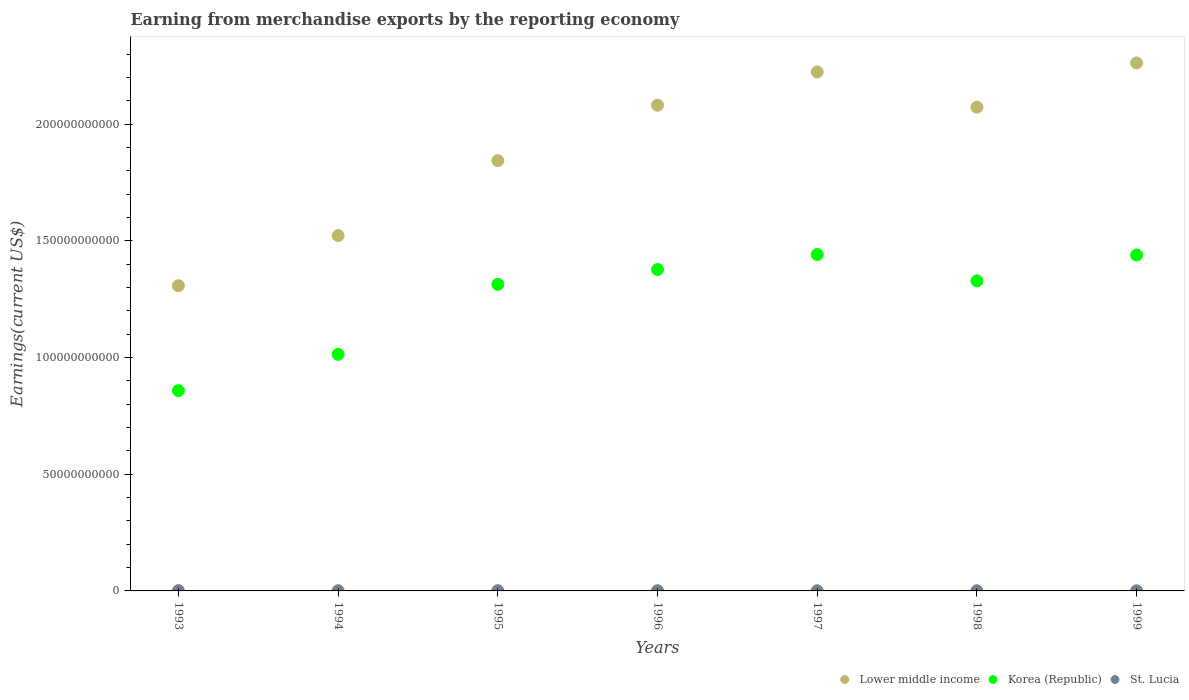How many different coloured dotlines are there?
Give a very brief answer. 3. Is the number of dotlines equal to the number of legend labels?
Offer a terse response. Yes. What is the amount earned from merchandise exports in Lower middle income in 1995?
Make the answer very short. 1.84e+11. Across all years, what is the maximum amount earned from merchandise exports in Lower middle income?
Offer a terse response. 2.26e+11. Across all years, what is the minimum amount earned from merchandise exports in Lower middle income?
Make the answer very short. 1.31e+11. In which year was the amount earned from merchandise exports in Korea (Republic) maximum?
Your response must be concise. 1997. In which year was the amount earned from merchandise exports in Lower middle income minimum?
Your answer should be compact. 1993. What is the total amount earned from merchandise exports in St. Lucia in the graph?
Make the answer very short. 5.82e+08. What is the difference between the amount earned from merchandise exports in Lower middle income in 1994 and that in 1996?
Your answer should be very brief. -5.59e+1. What is the difference between the amount earned from merchandise exports in Korea (Republic) in 1999 and the amount earned from merchandise exports in St. Lucia in 1996?
Offer a very short reply. 1.44e+11. What is the average amount earned from merchandise exports in Korea (Republic) per year?
Offer a very short reply. 1.25e+11. In the year 1996, what is the difference between the amount earned from merchandise exports in Korea (Republic) and amount earned from merchandise exports in St. Lucia?
Provide a short and direct response. 1.38e+11. In how many years, is the amount earned from merchandise exports in St. Lucia greater than 30000000000 US$?
Provide a succinct answer. 0. What is the ratio of the amount earned from merchandise exports in St. Lucia in 1994 to that in 1998?
Provide a succinct answer. 1.52. What is the difference between the highest and the second highest amount earned from merchandise exports in Lower middle income?
Offer a very short reply. 3.85e+09. What is the difference between the highest and the lowest amount earned from merchandise exports in St. Lucia?
Ensure brevity in your answer.  6.40e+07. In how many years, is the amount earned from merchandise exports in St. Lucia greater than the average amount earned from merchandise exports in St. Lucia taken over all years?
Ensure brevity in your answer.  3. Is the sum of the amount earned from merchandise exports in St. Lucia in 1995 and 1996 greater than the maximum amount earned from merchandise exports in Korea (Republic) across all years?
Give a very brief answer. No. Is the amount earned from merchandise exports in Lower middle income strictly less than the amount earned from merchandise exports in Korea (Republic) over the years?
Make the answer very short. No. How many dotlines are there?
Offer a very short reply. 3. How many years are there in the graph?
Ensure brevity in your answer.  7. What is the difference between two consecutive major ticks on the Y-axis?
Your answer should be very brief. 5.00e+1. Are the values on the major ticks of Y-axis written in scientific E-notation?
Your answer should be compact. No. Does the graph contain grids?
Provide a short and direct response. No. How many legend labels are there?
Keep it short and to the point. 3. How are the legend labels stacked?
Your answer should be very brief. Horizontal. What is the title of the graph?
Your answer should be compact. Earning from merchandise exports by the reporting economy. What is the label or title of the X-axis?
Your response must be concise. Years. What is the label or title of the Y-axis?
Keep it short and to the point. Earnings(current US$). What is the Earnings(current US$) in Lower middle income in 1993?
Offer a very short reply. 1.31e+11. What is the Earnings(current US$) of Korea (Republic) in 1993?
Your response must be concise. 8.58e+1. What is the Earnings(current US$) in St. Lucia in 1993?
Provide a succinct answer. 1.20e+08. What is the Earnings(current US$) in Lower middle income in 1994?
Give a very brief answer. 1.52e+11. What is the Earnings(current US$) of Korea (Republic) in 1994?
Provide a succinct answer. 1.01e+11. What is the Earnings(current US$) in St. Lucia in 1994?
Give a very brief answer. 9.44e+07. What is the Earnings(current US$) in Lower middle income in 1995?
Provide a short and direct response. 1.84e+11. What is the Earnings(current US$) of Korea (Republic) in 1995?
Make the answer very short. 1.31e+11. What is the Earnings(current US$) in St. Lucia in 1995?
Make the answer very short. 1.09e+08. What is the Earnings(current US$) of Lower middle income in 1996?
Keep it short and to the point. 2.08e+11. What is the Earnings(current US$) of Korea (Republic) in 1996?
Give a very brief answer. 1.38e+11. What is the Earnings(current US$) of St. Lucia in 1996?
Your response must be concise. 7.96e+07. What is the Earnings(current US$) of Lower middle income in 1997?
Provide a succinct answer. 2.22e+11. What is the Earnings(current US$) of Korea (Republic) in 1997?
Your answer should be compact. 1.44e+11. What is the Earnings(current US$) in St. Lucia in 1997?
Your answer should be very brief. 6.20e+07. What is the Earnings(current US$) of Lower middle income in 1998?
Your response must be concise. 2.07e+11. What is the Earnings(current US$) of Korea (Republic) in 1998?
Make the answer very short. 1.33e+11. What is the Earnings(current US$) in St. Lucia in 1998?
Give a very brief answer. 6.22e+07. What is the Earnings(current US$) of Lower middle income in 1999?
Offer a very short reply. 2.26e+11. What is the Earnings(current US$) of Korea (Republic) in 1999?
Your answer should be compact. 1.44e+11. What is the Earnings(current US$) in St. Lucia in 1999?
Your answer should be compact. 5.56e+07. Across all years, what is the maximum Earnings(current US$) in Lower middle income?
Keep it short and to the point. 2.26e+11. Across all years, what is the maximum Earnings(current US$) of Korea (Republic)?
Give a very brief answer. 1.44e+11. Across all years, what is the maximum Earnings(current US$) in St. Lucia?
Your answer should be very brief. 1.20e+08. Across all years, what is the minimum Earnings(current US$) in Lower middle income?
Offer a very short reply. 1.31e+11. Across all years, what is the minimum Earnings(current US$) in Korea (Republic)?
Make the answer very short. 8.58e+1. Across all years, what is the minimum Earnings(current US$) of St. Lucia?
Make the answer very short. 5.56e+07. What is the total Earnings(current US$) in Lower middle income in the graph?
Offer a terse response. 1.33e+12. What is the total Earnings(current US$) of Korea (Republic) in the graph?
Keep it short and to the point. 8.77e+11. What is the total Earnings(current US$) in St. Lucia in the graph?
Keep it short and to the point. 5.82e+08. What is the difference between the Earnings(current US$) in Lower middle income in 1993 and that in 1994?
Provide a short and direct response. -2.15e+1. What is the difference between the Earnings(current US$) of Korea (Republic) in 1993 and that in 1994?
Offer a terse response. -1.55e+1. What is the difference between the Earnings(current US$) in St. Lucia in 1993 and that in 1994?
Provide a succinct answer. 2.53e+07. What is the difference between the Earnings(current US$) of Lower middle income in 1993 and that in 1995?
Give a very brief answer. -5.36e+1. What is the difference between the Earnings(current US$) in Korea (Republic) in 1993 and that in 1995?
Keep it short and to the point. -4.55e+1. What is the difference between the Earnings(current US$) in St. Lucia in 1993 and that in 1995?
Your response must be concise. 1.07e+07. What is the difference between the Earnings(current US$) in Lower middle income in 1993 and that in 1996?
Your response must be concise. -7.73e+1. What is the difference between the Earnings(current US$) in Korea (Republic) in 1993 and that in 1996?
Your answer should be compact. -5.19e+1. What is the difference between the Earnings(current US$) of St. Lucia in 1993 and that in 1996?
Keep it short and to the point. 4.01e+07. What is the difference between the Earnings(current US$) in Lower middle income in 1993 and that in 1997?
Ensure brevity in your answer.  -9.16e+1. What is the difference between the Earnings(current US$) in Korea (Republic) in 1993 and that in 1997?
Provide a short and direct response. -5.83e+1. What is the difference between the Earnings(current US$) in St. Lucia in 1993 and that in 1997?
Keep it short and to the point. 5.76e+07. What is the difference between the Earnings(current US$) of Lower middle income in 1993 and that in 1998?
Keep it short and to the point. -7.65e+1. What is the difference between the Earnings(current US$) of Korea (Republic) in 1993 and that in 1998?
Your answer should be compact. -4.70e+1. What is the difference between the Earnings(current US$) of St. Lucia in 1993 and that in 1998?
Provide a succinct answer. 5.75e+07. What is the difference between the Earnings(current US$) in Lower middle income in 1993 and that in 1999?
Your answer should be compact. -9.54e+1. What is the difference between the Earnings(current US$) in Korea (Republic) in 1993 and that in 1999?
Provide a short and direct response. -5.81e+1. What is the difference between the Earnings(current US$) in St. Lucia in 1993 and that in 1999?
Your response must be concise. 6.40e+07. What is the difference between the Earnings(current US$) in Lower middle income in 1994 and that in 1995?
Offer a very short reply. -3.21e+1. What is the difference between the Earnings(current US$) of Korea (Republic) in 1994 and that in 1995?
Give a very brief answer. -3.00e+1. What is the difference between the Earnings(current US$) in St. Lucia in 1994 and that in 1995?
Give a very brief answer. -1.46e+07. What is the difference between the Earnings(current US$) in Lower middle income in 1994 and that in 1996?
Your answer should be very brief. -5.59e+1. What is the difference between the Earnings(current US$) in Korea (Republic) in 1994 and that in 1996?
Offer a terse response. -3.63e+1. What is the difference between the Earnings(current US$) of St. Lucia in 1994 and that in 1996?
Provide a succinct answer. 1.48e+07. What is the difference between the Earnings(current US$) of Lower middle income in 1994 and that in 1997?
Make the answer very short. -7.01e+1. What is the difference between the Earnings(current US$) in Korea (Republic) in 1994 and that in 1997?
Provide a succinct answer. -4.28e+1. What is the difference between the Earnings(current US$) in St. Lucia in 1994 and that in 1997?
Ensure brevity in your answer.  3.23e+07. What is the difference between the Earnings(current US$) in Lower middle income in 1994 and that in 1998?
Your response must be concise. -5.50e+1. What is the difference between the Earnings(current US$) in Korea (Republic) in 1994 and that in 1998?
Keep it short and to the point. -3.15e+1. What is the difference between the Earnings(current US$) in St. Lucia in 1994 and that in 1998?
Your response must be concise. 3.22e+07. What is the difference between the Earnings(current US$) of Lower middle income in 1994 and that in 1999?
Provide a succinct answer. -7.40e+1. What is the difference between the Earnings(current US$) in Korea (Republic) in 1994 and that in 1999?
Make the answer very short. -4.26e+1. What is the difference between the Earnings(current US$) in St. Lucia in 1994 and that in 1999?
Your answer should be compact. 3.87e+07. What is the difference between the Earnings(current US$) of Lower middle income in 1995 and that in 1996?
Provide a short and direct response. -2.38e+1. What is the difference between the Earnings(current US$) of Korea (Republic) in 1995 and that in 1996?
Offer a very short reply. -6.36e+09. What is the difference between the Earnings(current US$) of St. Lucia in 1995 and that in 1996?
Your response must be concise. 2.94e+07. What is the difference between the Earnings(current US$) of Lower middle income in 1995 and that in 1997?
Your response must be concise. -3.80e+1. What is the difference between the Earnings(current US$) of Korea (Republic) in 1995 and that in 1997?
Provide a succinct answer. -1.28e+1. What is the difference between the Earnings(current US$) of St. Lucia in 1995 and that in 1997?
Offer a very short reply. 4.70e+07. What is the difference between the Earnings(current US$) of Lower middle income in 1995 and that in 1998?
Make the answer very short. -2.29e+1. What is the difference between the Earnings(current US$) of Korea (Republic) in 1995 and that in 1998?
Your response must be concise. -1.49e+09. What is the difference between the Earnings(current US$) of St. Lucia in 1995 and that in 1998?
Your answer should be very brief. 4.68e+07. What is the difference between the Earnings(current US$) in Lower middle income in 1995 and that in 1999?
Provide a short and direct response. -4.19e+1. What is the difference between the Earnings(current US$) of Korea (Republic) in 1995 and that in 1999?
Your answer should be compact. -1.26e+1. What is the difference between the Earnings(current US$) in St. Lucia in 1995 and that in 1999?
Provide a succinct answer. 5.33e+07. What is the difference between the Earnings(current US$) of Lower middle income in 1996 and that in 1997?
Keep it short and to the point. -1.42e+1. What is the difference between the Earnings(current US$) of Korea (Republic) in 1996 and that in 1997?
Offer a terse response. -6.42e+09. What is the difference between the Earnings(current US$) of St. Lucia in 1996 and that in 1997?
Your answer should be compact. 1.75e+07. What is the difference between the Earnings(current US$) of Lower middle income in 1996 and that in 1998?
Your response must be concise. 8.60e+08. What is the difference between the Earnings(current US$) in Korea (Republic) in 1996 and that in 1998?
Provide a short and direct response. 4.86e+09. What is the difference between the Earnings(current US$) in St. Lucia in 1996 and that in 1998?
Your answer should be compact. 1.74e+07. What is the difference between the Earnings(current US$) of Lower middle income in 1996 and that in 1999?
Offer a very short reply. -1.81e+1. What is the difference between the Earnings(current US$) of Korea (Republic) in 1996 and that in 1999?
Your answer should be very brief. -6.22e+09. What is the difference between the Earnings(current US$) of St. Lucia in 1996 and that in 1999?
Ensure brevity in your answer.  2.39e+07. What is the difference between the Earnings(current US$) in Lower middle income in 1997 and that in 1998?
Ensure brevity in your answer.  1.51e+1. What is the difference between the Earnings(current US$) of Korea (Republic) in 1997 and that in 1998?
Make the answer very short. 1.13e+1. What is the difference between the Earnings(current US$) in St. Lucia in 1997 and that in 1998?
Provide a short and direct response. -1.51e+05. What is the difference between the Earnings(current US$) in Lower middle income in 1997 and that in 1999?
Offer a terse response. -3.85e+09. What is the difference between the Earnings(current US$) of Korea (Republic) in 1997 and that in 1999?
Ensure brevity in your answer.  2.02e+08. What is the difference between the Earnings(current US$) in St. Lucia in 1997 and that in 1999?
Provide a short and direct response. 6.37e+06. What is the difference between the Earnings(current US$) in Lower middle income in 1998 and that in 1999?
Ensure brevity in your answer.  -1.89e+1. What is the difference between the Earnings(current US$) of Korea (Republic) in 1998 and that in 1999?
Make the answer very short. -1.11e+1. What is the difference between the Earnings(current US$) in St. Lucia in 1998 and that in 1999?
Give a very brief answer. 6.52e+06. What is the difference between the Earnings(current US$) of Lower middle income in 1993 and the Earnings(current US$) of Korea (Republic) in 1994?
Your answer should be very brief. 2.94e+1. What is the difference between the Earnings(current US$) in Lower middle income in 1993 and the Earnings(current US$) in St. Lucia in 1994?
Provide a short and direct response. 1.31e+11. What is the difference between the Earnings(current US$) in Korea (Republic) in 1993 and the Earnings(current US$) in St. Lucia in 1994?
Keep it short and to the point. 8.57e+1. What is the difference between the Earnings(current US$) in Lower middle income in 1993 and the Earnings(current US$) in Korea (Republic) in 1995?
Provide a short and direct response. -5.76e+08. What is the difference between the Earnings(current US$) of Lower middle income in 1993 and the Earnings(current US$) of St. Lucia in 1995?
Your answer should be very brief. 1.31e+11. What is the difference between the Earnings(current US$) in Korea (Republic) in 1993 and the Earnings(current US$) in St. Lucia in 1995?
Keep it short and to the point. 8.57e+1. What is the difference between the Earnings(current US$) in Lower middle income in 1993 and the Earnings(current US$) in Korea (Republic) in 1996?
Provide a succinct answer. -6.93e+09. What is the difference between the Earnings(current US$) of Lower middle income in 1993 and the Earnings(current US$) of St. Lucia in 1996?
Offer a terse response. 1.31e+11. What is the difference between the Earnings(current US$) of Korea (Republic) in 1993 and the Earnings(current US$) of St. Lucia in 1996?
Provide a short and direct response. 8.57e+1. What is the difference between the Earnings(current US$) in Lower middle income in 1993 and the Earnings(current US$) in Korea (Republic) in 1997?
Offer a very short reply. -1.34e+1. What is the difference between the Earnings(current US$) in Lower middle income in 1993 and the Earnings(current US$) in St. Lucia in 1997?
Offer a very short reply. 1.31e+11. What is the difference between the Earnings(current US$) of Korea (Republic) in 1993 and the Earnings(current US$) of St. Lucia in 1997?
Offer a terse response. 8.58e+1. What is the difference between the Earnings(current US$) in Lower middle income in 1993 and the Earnings(current US$) in Korea (Republic) in 1998?
Provide a short and direct response. -2.07e+09. What is the difference between the Earnings(current US$) in Lower middle income in 1993 and the Earnings(current US$) in St. Lucia in 1998?
Offer a very short reply. 1.31e+11. What is the difference between the Earnings(current US$) of Korea (Republic) in 1993 and the Earnings(current US$) of St. Lucia in 1998?
Your answer should be compact. 8.58e+1. What is the difference between the Earnings(current US$) in Lower middle income in 1993 and the Earnings(current US$) in Korea (Republic) in 1999?
Keep it short and to the point. -1.32e+1. What is the difference between the Earnings(current US$) in Lower middle income in 1993 and the Earnings(current US$) in St. Lucia in 1999?
Ensure brevity in your answer.  1.31e+11. What is the difference between the Earnings(current US$) in Korea (Republic) in 1993 and the Earnings(current US$) in St. Lucia in 1999?
Make the answer very short. 8.58e+1. What is the difference between the Earnings(current US$) in Lower middle income in 1994 and the Earnings(current US$) in Korea (Republic) in 1995?
Your response must be concise. 2.09e+1. What is the difference between the Earnings(current US$) of Lower middle income in 1994 and the Earnings(current US$) of St. Lucia in 1995?
Offer a very short reply. 1.52e+11. What is the difference between the Earnings(current US$) of Korea (Republic) in 1994 and the Earnings(current US$) of St. Lucia in 1995?
Your answer should be very brief. 1.01e+11. What is the difference between the Earnings(current US$) in Lower middle income in 1994 and the Earnings(current US$) in Korea (Republic) in 1996?
Make the answer very short. 1.45e+1. What is the difference between the Earnings(current US$) of Lower middle income in 1994 and the Earnings(current US$) of St. Lucia in 1996?
Give a very brief answer. 1.52e+11. What is the difference between the Earnings(current US$) in Korea (Republic) in 1994 and the Earnings(current US$) in St. Lucia in 1996?
Ensure brevity in your answer.  1.01e+11. What is the difference between the Earnings(current US$) in Lower middle income in 1994 and the Earnings(current US$) in Korea (Republic) in 1997?
Offer a terse response. 8.11e+09. What is the difference between the Earnings(current US$) in Lower middle income in 1994 and the Earnings(current US$) in St. Lucia in 1997?
Your response must be concise. 1.52e+11. What is the difference between the Earnings(current US$) in Korea (Republic) in 1994 and the Earnings(current US$) in St. Lucia in 1997?
Provide a succinct answer. 1.01e+11. What is the difference between the Earnings(current US$) of Lower middle income in 1994 and the Earnings(current US$) of Korea (Republic) in 1998?
Make the answer very short. 1.94e+1. What is the difference between the Earnings(current US$) of Lower middle income in 1994 and the Earnings(current US$) of St. Lucia in 1998?
Provide a short and direct response. 1.52e+11. What is the difference between the Earnings(current US$) in Korea (Republic) in 1994 and the Earnings(current US$) in St. Lucia in 1998?
Give a very brief answer. 1.01e+11. What is the difference between the Earnings(current US$) of Lower middle income in 1994 and the Earnings(current US$) of Korea (Republic) in 1999?
Offer a terse response. 8.32e+09. What is the difference between the Earnings(current US$) of Lower middle income in 1994 and the Earnings(current US$) of St. Lucia in 1999?
Provide a succinct answer. 1.52e+11. What is the difference between the Earnings(current US$) in Korea (Republic) in 1994 and the Earnings(current US$) in St. Lucia in 1999?
Keep it short and to the point. 1.01e+11. What is the difference between the Earnings(current US$) in Lower middle income in 1995 and the Earnings(current US$) in Korea (Republic) in 1996?
Offer a very short reply. 4.66e+1. What is the difference between the Earnings(current US$) in Lower middle income in 1995 and the Earnings(current US$) in St. Lucia in 1996?
Ensure brevity in your answer.  1.84e+11. What is the difference between the Earnings(current US$) of Korea (Republic) in 1995 and the Earnings(current US$) of St. Lucia in 1996?
Make the answer very short. 1.31e+11. What is the difference between the Earnings(current US$) of Lower middle income in 1995 and the Earnings(current US$) of Korea (Republic) in 1997?
Your response must be concise. 4.02e+1. What is the difference between the Earnings(current US$) of Lower middle income in 1995 and the Earnings(current US$) of St. Lucia in 1997?
Your response must be concise. 1.84e+11. What is the difference between the Earnings(current US$) in Korea (Republic) in 1995 and the Earnings(current US$) in St. Lucia in 1997?
Your answer should be very brief. 1.31e+11. What is the difference between the Earnings(current US$) of Lower middle income in 1995 and the Earnings(current US$) of Korea (Republic) in 1998?
Offer a very short reply. 5.15e+1. What is the difference between the Earnings(current US$) of Lower middle income in 1995 and the Earnings(current US$) of St. Lucia in 1998?
Make the answer very short. 1.84e+11. What is the difference between the Earnings(current US$) of Korea (Republic) in 1995 and the Earnings(current US$) of St. Lucia in 1998?
Your answer should be compact. 1.31e+11. What is the difference between the Earnings(current US$) of Lower middle income in 1995 and the Earnings(current US$) of Korea (Republic) in 1999?
Your answer should be compact. 4.04e+1. What is the difference between the Earnings(current US$) in Lower middle income in 1995 and the Earnings(current US$) in St. Lucia in 1999?
Ensure brevity in your answer.  1.84e+11. What is the difference between the Earnings(current US$) of Korea (Republic) in 1995 and the Earnings(current US$) of St. Lucia in 1999?
Your answer should be compact. 1.31e+11. What is the difference between the Earnings(current US$) of Lower middle income in 1996 and the Earnings(current US$) of Korea (Republic) in 1997?
Offer a terse response. 6.40e+1. What is the difference between the Earnings(current US$) of Lower middle income in 1996 and the Earnings(current US$) of St. Lucia in 1997?
Offer a very short reply. 2.08e+11. What is the difference between the Earnings(current US$) of Korea (Republic) in 1996 and the Earnings(current US$) of St. Lucia in 1997?
Offer a very short reply. 1.38e+11. What is the difference between the Earnings(current US$) of Lower middle income in 1996 and the Earnings(current US$) of Korea (Republic) in 1998?
Your answer should be very brief. 7.53e+1. What is the difference between the Earnings(current US$) of Lower middle income in 1996 and the Earnings(current US$) of St. Lucia in 1998?
Make the answer very short. 2.08e+11. What is the difference between the Earnings(current US$) in Korea (Republic) in 1996 and the Earnings(current US$) in St. Lucia in 1998?
Offer a very short reply. 1.38e+11. What is the difference between the Earnings(current US$) of Lower middle income in 1996 and the Earnings(current US$) of Korea (Republic) in 1999?
Your answer should be very brief. 6.42e+1. What is the difference between the Earnings(current US$) of Lower middle income in 1996 and the Earnings(current US$) of St. Lucia in 1999?
Provide a succinct answer. 2.08e+11. What is the difference between the Earnings(current US$) of Korea (Republic) in 1996 and the Earnings(current US$) of St. Lucia in 1999?
Make the answer very short. 1.38e+11. What is the difference between the Earnings(current US$) of Lower middle income in 1997 and the Earnings(current US$) of Korea (Republic) in 1998?
Give a very brief answer. 8.95e+1. What is the difference between the Earnings(current US$) of Lower middle income in 1997 and the Earnings(current US$) of St. Lucia in 1998?
Your answer should be very brief. 2.22e+11. What is the difference between the Earnings(current US$) in Korea (Republic) in 1997 and the Earnings(current US$) in St. Lucia in 1998?
Your answer should be compact. 1.44e+11. What is the difference between the Earnings(current US$) in Lower middle income in 1997 and the Earnings(current US$) in Korea (Republic) in 1999?
Ensure brevity in your answer.  7.84e+1. What is the difference between the Earnings(current US$) in Lower middle income in 1997 and the Earnings(current US$) in St. Lucia in 1999?
Your response must be concise. 2.22e+11. What is the difference between the Earnings(current US$) in Korea (Republic) in 1997 and the Earnings(current US$) in St. Lucia in 1999?
Offer a terse response. 1.44e+11. What is the difference between the Earnings(current US$) of Lower middle income in 1998 and the Earnings(current US$) of Korea (Republic) in 1999?
Your answer should be very brief. 6.33e+1. What is the difference between the Earnings(current US$) of Lower middle income in 1998 and the Earnings(current US$) of St. Lucia in 1999?
Your response must be concise. 2.07e+11. What is the difference between the Earnings(current US$) of Korea (Republic) in 1998 and the Earnings(current US$) of St. Lucia in 1999?
Your answer should be very brief. 1.33e+11. What is the average Earnings(current US$) of Lower middle income per year?
Give a very brief answer. 1.90e+11. What is the average Earnings(current US$) of Korea (Republic) per year?
Your answer should be compact. 1.25e+11. What is the average Earnings(current US$) in St. Lucia per year?
Provide a short and direct response. 8.32e+07. In the year 1993, what is the difference between the Earnings(current US$) in Lower middle income and Earnings(current US$) in Korea (Republic)?
Keep it short and to the point. 4.50e+1. In the year 1993, what is the difference between the Earnings(current US$) in Lower middle income and Earnings(current US$) in St. Lucia?
Make the answer very short. 1.31e+11. In the year 1993, what is the difference between the Earnings(current US$) in Korea (Republic) and Earnings(current US$) in St. Lucia?
Your answer should be compact. 8.57e+1. In the year 1994, what is the difference between the Earnings(current US$) of Lower middle income and Earnings(current US$) of Korea (Republic)?
Offer a very short reply. 5.09e+1. In the year 1994, what is the difference between the Earnings(current US$) of Lower middle income and Earnings(current US$) of St. Lucia?
Offer a very short reply. 1.52e+11. In the year 1994, what is the difference between the Earnings(current US$) of Korea (Republic) and Earnings(current US$) of St. Lucia?
Keep it short and to the point. 1.01e+11. In the year 1995, what is the difference between the Earnings(current US$) in Lower middle income and Earnings(current US$) in Korea (Republic)?
Offer a very short reply. 5.30e+1. In the year 1995, what is the difference between the Earnings(current US$) in Lower middle income and Earnings(current US$) in St. Lucia?
Your answer should be very brief. 1.84e+11. In the year 1995, what is the difference between the Earnings(current US$) in Korea (Republic) and Earnings(current US$) in St. Lucia?
Your answer should be very brief. 1.31e+11. In the year 1996, what is the difference between the Earnings(current US$) in Lower middle income and Earnings(current US$) in Korea (Republic)?
Your answer should be very brief. 7.04e+1. In the year 1996, what is the difference between the Earnings(current US$) of Lower middle income and Earnings(current US$) of St. Lucia?
Make the answer very short. 2.08e+11. In the year 1996, what is the difference between the Earnings(current US$) of Korea (Republic) and Earnings(current US$) of St. Lucia?
Offer a terse response. 1.38e+11. In the year 1997, what is the difference between the Earnings(current US$) of Lower middle income and Earnings(current US$) of Korea (Republic)?
Ensure brevity in your answer.  7.82e+1. In the year 1997, what is the difference between the Earnings(current US$) of Lower middle income and Earnings(current US$) of St. Lucia?
Ensure brevity in your answer.  2.22e+11. In the year 1997, what is the difference between the Earnings(current US$) in Korea (Republic) and Earnings(current US$) in St. Lucia?
Offer a very short reply. 1.44e+11. In the year 1998, what is the difference between the Earnings(current US$) of Lower middle income and Earnings(current US$) of Korea (Republic)?
Offer a very short reply. 7.44e+1. In the year 1998, what is the difference between the Earnings(current US$) of Lower middle income and Earnings(current US$) of St. Lucia?
Your answer should be very brief. 2.07e+11. In the year 1998, what is the difference between the Earnings(current US$) of Korea (Republic) and Earnings(current US$) of St. Lucia?
Provide a succinct answer. 1.33e+11. In the year 1999, what is the difference between the Earnings(current US$) in Lower middle income and Earnings(current US$) in Korea (Republic)?
Your response must be concise. 8.23e+1. In the year 1999, what is the difference between the Earnings(current US$) in Lower middle income and Earnings(current US$) in St. Lucia?
Give a very brief answer. 2.26e+11. In the year 1999, what is the difference between the Earnings(current US$) in Korea (Republic) and Earnings(current US$) in St. Lucia?
Your answer should be very brief. 1.44e+11. What is the ratio of the Earnings(current US$) in Lower middle income in 1993 to that in 1994?
Make the answer very short. 0.86. What is the ratio of the Earnings(current US$) of Korea (Republic) in 1993 to that in 1994?
Offer a very short reply. 0.85. What is the ratio of the Earnings(current US$) of St. Lucia in 1993 to that in 1994?
Your answer should be very brief. 1.27. What is the ratio of the Earnings(current US$) of Lower middle income in 1993 to that in 1995?
Your answer should be compact. 0.71. What is the ratio of the Earnings(current US$) of Korea (Republic) in 1993 to that in 1995?
Ensure brevity in your answer.  0.65. What is the ratio of the Earnings(current US$) of St. Lucia in 1993 to that in 1995?
Offer a terse response. 1.1. What is the ratio of the Earnings(current US$) in Lower middle income in 1993 to that in 1996?
Give a very brief answer. 0.63. What is the ratio of the Earnings(current US$) of Korea (Republic) in 1993 to that in 1996?
Make the answer very short. 0.62. What is the ratio of the Earnings(current US$) in St. Lucia in 1993 to that in 1996?
Your answer should be very brief. 1.5. What is the ratio of the Earnings(current US$) of Lower middle income in 1993 to that in 1997?
Give a very brief answer. 0.59. What is the ratio of the Earnings(current US$) in Korea (Republic) in 1993 to that in 1997?
Offer a very short reply. 0.6. What is the ratio of the Earnings(current US$) of St. Lucia in 1993 to that in 1997?
Offer a terse response. 1.93. What is the ratio of the Earnings(current US$) in Lower middle income in 1993 to that in 1998?
Provide a short and direct response. 0.63. What is the ratio of the Earnings(current US$) of Korea (Republic) in 1993 to that in 1998?
Make the answer very short. 0.65. What is the ratio of the Earnings(current US$) of St. Lucia in 1993 to that in 1998?
Provide a short and direct response. 1.92. What is the ratio of the Earnings(current US$) in Lower middle income in 1993 to that in 1999?
Provide a short and direct response. 0.58. What is the ratio of the Earnings(current US$) of Korea (Republic) in 1993 to that in 1999?
Provide a short and direct response. 0.6. What is the ratio of the Earnings(current US$) in St. Lucia in 1993 to that in 1999?
Your answer should be compact. 2.15. What is the ratio of the Earnings(current US$) in Lower middle income in 1994 to that in 1995?
Ensure brevity in your answer.  0.83. What is the ratio of the Earnings(current US$) in Korea (Republic) in 1994 to that in 1995?
Your answer should be very brief. 0.77. What is the ratio of the Earnings(current US$) in St. Lucia in 1994 to that in 1995?
Your response must be concise. 0.87. What is the ratio of the Earnings(current US$) of Lower middle income in 1994 to that in 1996?
Your response must be concise. 0.73. What is the ratio of the Earnings(current US$) in Korea (Republic) in 1994 to that in 1996?
Provide a succinct answer. 0.74. What is the ratio of the Earnings(current US$) of St. Lucia in 1994 to that in 1996?
Your response must be concise. 1.19. What is the ratio of the Earnings(current US$) in Lower middle income in 1994 to that in 1997?
Your answer should be compact. 0.68. What is the ratio of the Earnings(current US$) of Korea (Republic) in 1994 to that in 1997?
Make the answer very short. 0.7. What is the ratio of the Earnings(current US$) in St. Lucia in 1994 to that in 1997?
Offer a very short reply. 1.52. What is the ratio of the Earnings(current US$) in Lower middle income in 1994 to that in 1998?
Your answer should be compact. 0.73. What is the ratio of the Earnings(current US$) of Korea (Republic) in 1994 to that in 1998?
Your answer should be compact. 0.76. What is the ratio of the Earnings(current US$) in St. Lucia in 1994 to that in 1998?
Make the answer very short. 1.52. What is the ratio of the Earnings(current US$) of Lower middle income in 1994 to that in 1999?
Give a very brief answer. 0.67. What is the ratio of the Earnings(current US$) of Korea (Republic) in 1994 to that in 1999?
Provide a short and direct response. 0.7. What is the ratio of the Earnings(current US$) of St. Lucia in 1994 to that in 1999?
Ensure brevity in your answer.  1.7. What is the ratio of the Earnings(current US$) in Lower middle income in 1995 to that in 1996?
Your answer should be compact. 0.89. What is the ratio of the Earnings(current US$) of Korea (Republic) in 1995 to that in 1996?
Ensure brevity in your answer.  0.95. What is the ratio of the Earnings(current US$) in St. Lucia in 1995 to that in 1996?
Your response must be concise. 1.37. What is the ratio of the Earnings(current US$) in Lower middle income in 1995 to that in 1997?
Make the answer very short. 0.83. What is the ratio of the Earnings(current US$) of Korea (Republic) in 1995 to that in 1997?
Provide a succinct answer. 0.91. What is the ratio of the Earnings(current US$) in St. Lucia in 1995 to that in 1997?
Your answer should be very brief. 1.76. What is the ratio of the Earnings(current US$) of Lower middle income in 1995 to that in 1998?
Offer a terse response. 0.89. What is the ratio of the Earnings(current US$) in Korea (Republic) in 1995 to that in 1998?
Make the answer very short. 0.99. What is the ratio of the Earnings(current US$) of St. Lucia in 1995 to that in 1998?
Your response must be concise. 1.75. What is the ratio of the Earnings(current US$) in Lower middle income in 1995 to that in 1999?
Your answer should be very brief. 0.81. What is the ratio of the Earnings(current US$) in Korea (Republic) in 1995 to that in 1999?
Provide a short and direct response. 0.91. What is the ratio of the Earnings(current US$) of St. Lucia in 1995 to that in 1999?
Your answer should be compact. 1.96. What is the ratio of the Earnings(current US$) in Lower middle income in 1996 to that in 1997?
Provide a succinct answer. 0.94. What is the ratio of the Earnings(current US$) of Korea (Republic) in 1996 to that in 1997?
Offer a terse response. 0.96. What is the ratio of the Earnings(current US$) in St. Lucia in 1996 to that in 1997?
Offer a very short reply. 1.28. What is the ratio of the Earnings(current US$) in Lower middle income in 1996 to that in 1998?
Ensure brevity in your answer.  1. What is the ratio of the Earnings(current US$) of Korea (Republic) in 1996 to that in 1998?
Keep it short and to the point. 1.04. What is the ratio of the Earnings(current US$) in St. Lucia in 1996 to that in 1998?
Make the answer very short. 1.28. What is the ratio of the Earnings(current US$) in Lower middle income in 1996 to that in 1999?
Your response must be concise. 0.92. What is the ratio of the Earnings(current US$) of Korea (Republic) in 1996 to that in 1999?
Give a very brief answer. 0.96. What is the ratio of the Earnings(current US$) of St. Lucia in 1996 to that in 1999?
Your answer should be very brief. 1.43. What is the ratio of the Earnings(current US$) of Lower middle income in 1997 to that in 1998?
Your answer should be compact. 1.07. What is the ratio of the Earnings(current US$) of Korea (Republic) in 1997 to that in 1998?
Keep it short and to the point. 1.08. What is the ratio of the Earnings(current US$) of Korea (Republic) in 1997 to that in 1999?
Ensure brevity in your answer.  1. What is the ratio of the Earnings(current US$) of St. Lucia in 1997 to that in 1999?
Make the answer very short. 1.11. What is the ratio of the Earnings(current US$) in Lower middle income in 1998 to that in 1999?
Offer a very short reply. 0.92. What is the ratio of the Earnings(current US$) in Korea (Republic) in 1998 to that in 1999?
Your answer should be compact. 0.92. What is the ratio of the Earnings(current US$) of St. Lucia in 1998 to that in 1999?
Offer a terse response. 1.12. What is the difference between the highest and the second highest Earnings(current US$) of Lower middle income?
Offer a very short reply. 3.85e+09. What is the difference between the highest and the second highest Earnings(current US$) in Korea (Republic)?
Offer a terse response. 2.02e+08. What is the difference between the highest and the second highest Earnings(current US$) in St. Lucia?
Provide a succinct answer. 1.07e+07. What is the difference between the highest and the lowest Earnings(current US$) in Lower middle income?
Your answer should be very brief. 9.54e+1. What is the difference between the highest and the lowest Earnings(current US$) in Korea (Republic)?
Make the answer very short. 5.83e+1. What is the difference between the highest and the lowest Earnings(current US$) of St. Lucia?
Provide a short and direct response. 6.40e+07. 